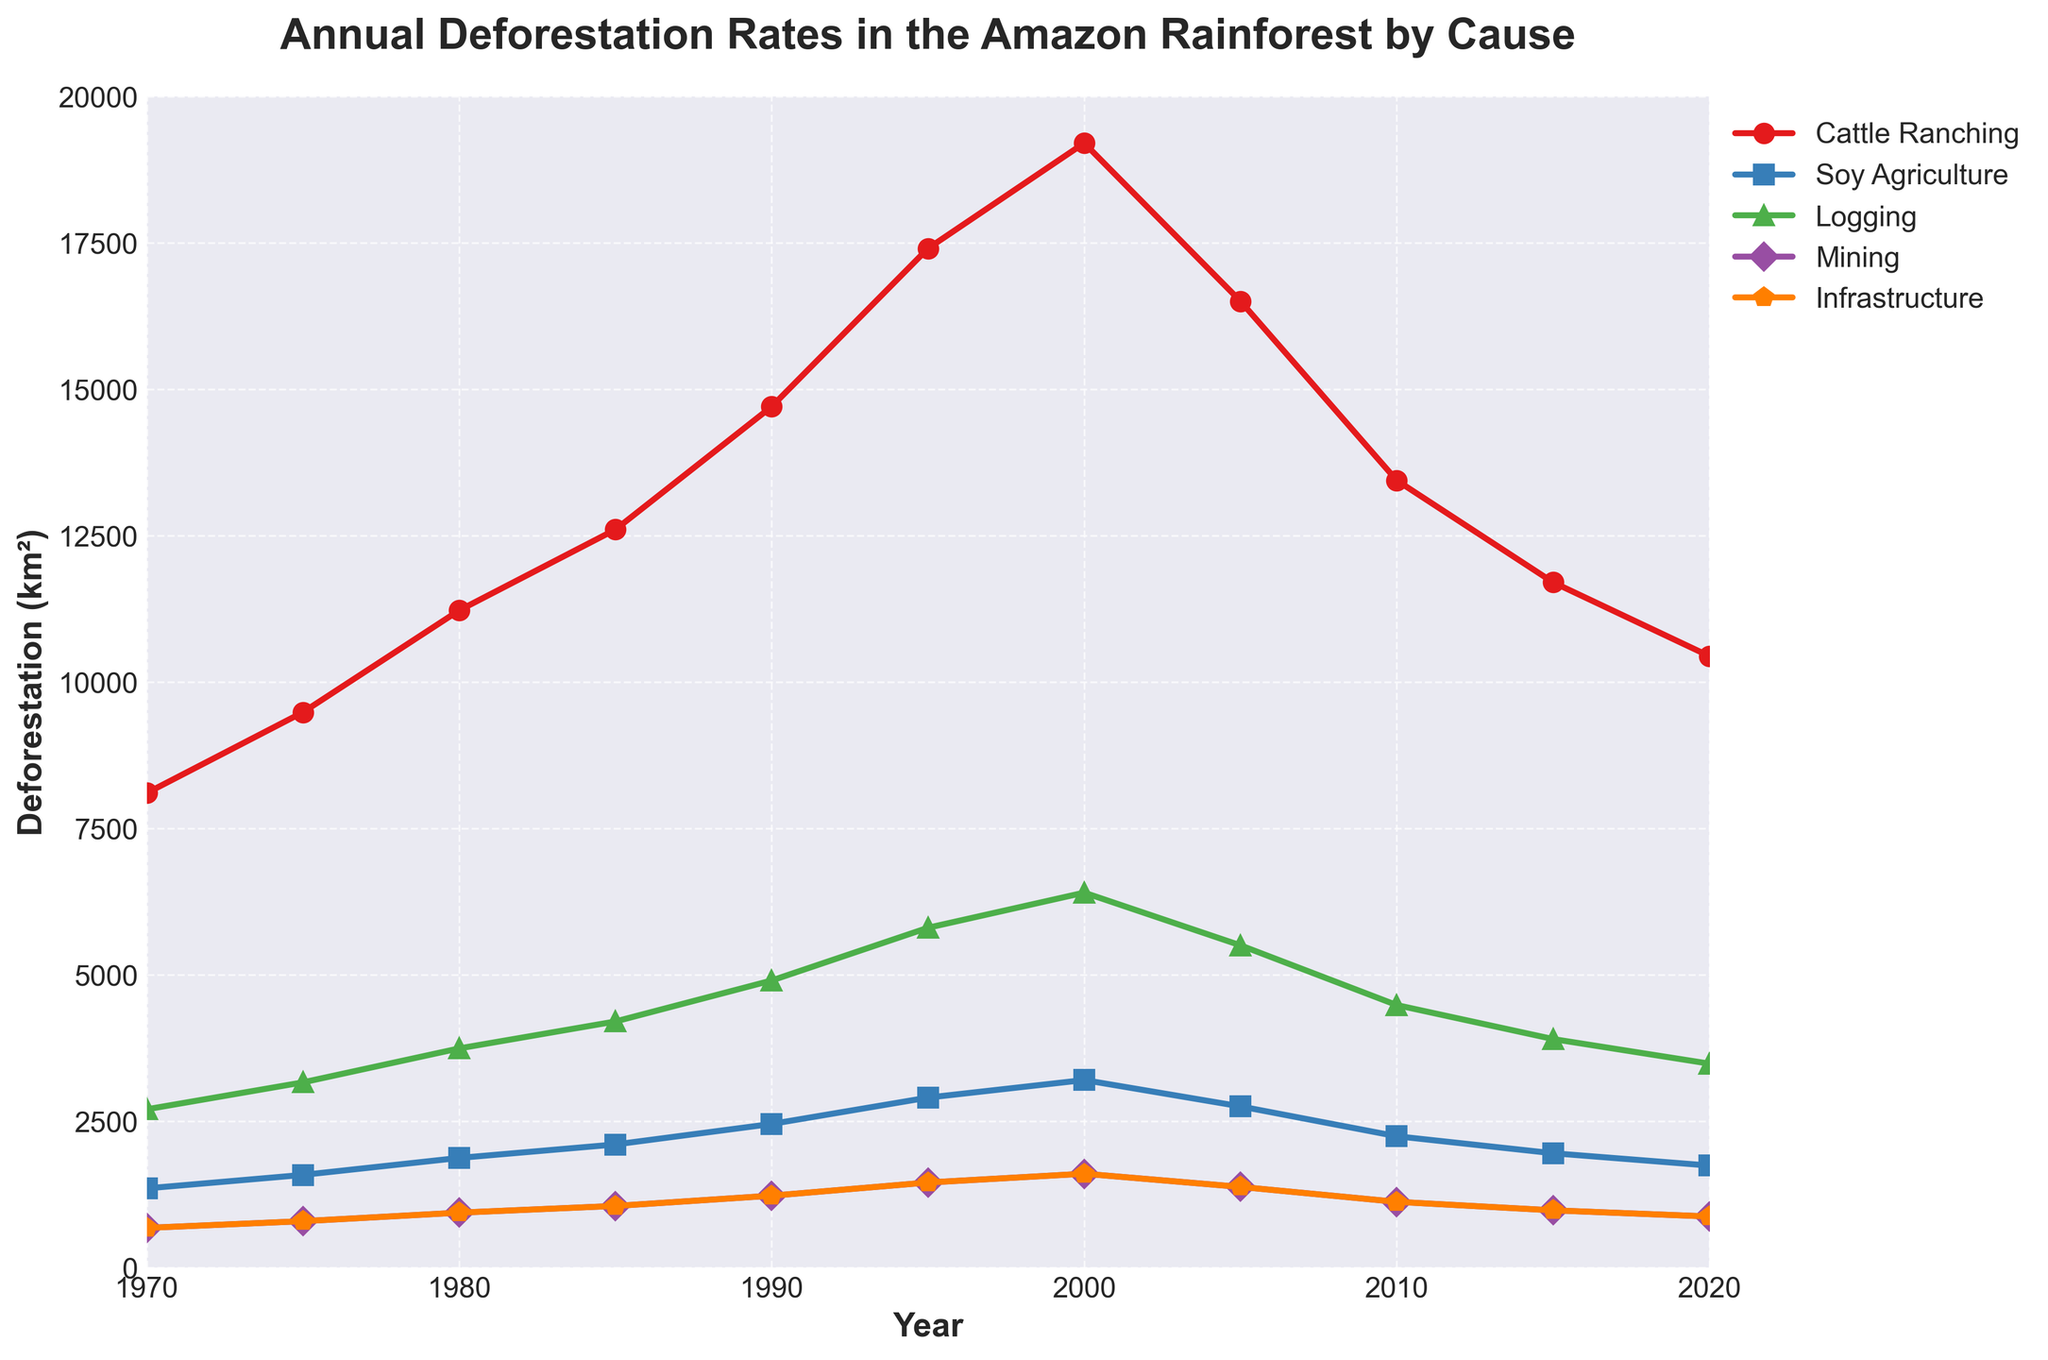What was the total deforestation caused by cattle ranching in 1980? The figure shows that the deforestation caused by cattle ranching in 1980 is indicated by the height of the respective line on the plot. The value at 1980 for cattle ranching is 11220 km².
Answer: 11220 km² Between 1975 and 2000, which cause of deforestation had the greatest increase? By comparing the values at 1975 and 2000 for all causes, we observe the following increases: cattle ranching (19200 - 9480 = 9720 km²), soy agriculture (3200 - 1580 = 1620 km²), logging (6400 - 3160 = 3240 km²), mining (1600 - 790 = 810 km²), and infrastructure (1600 - 790 = 810 km²). The greatest increase is in cattle ranching with an increment of 9720 km².
Answer: Cattle Ranching Which year had the highest total deforestation rate, and what was the value? The highest total deforestation rate corresponds to the highest point on the 'Total Deforestation' line. The figure shows that the peak occurred in 2000 with a value of 32000 km².
Answer: 2000, 32000 km² Compare the deforestation caused by logging and mining in 1990. Which was higher, and by how much? The figure shows the deforestation for logging in 1990 is 4900 km² and for mining is 1225 km². Logging is higher. The difference is 4900 - 1225 = 3675 km².
Answer: Logging by 3675 km² What is the average annual deforestation caused by infrastructure from 1970 to 2020? Sum the values for infrastructure from 1970 to 2020 (675 + 790 + 935 + 1050 + 1225 + 1450 + 1600 + 1375 + 1120 + 975 + 870 = 12065 km²) and then divide by the number of years (2020 - 1970 = 50 years). The average annual deforestation is 12065 / 50 = 241.3 km².
Answer: 241.3 km² Identify the two primary causes of deforestation and explain how their trend lines differ over the period from 1970 to 2020. The primary causes are cattle ranching and soy agriculture. Cattle ranching shows a steady increase, peaking in 2000 and slightly declining afterward. Soy agriculture peaks similarly but at a much lower value. Over time, cattle ranching consistently causes more deforestation compared to soy agriculture.
Answer: Cattle Ranching increased more steadily; Soy agriculture was always lower By how much did the total deforestation rate change from 2000 to 2005? The total deforestation in 2000 is 32000 km² and in 2005 is 27500 km². The change is 32000 - 27500 = -4500 km². This represents a decrease in the deforestation rate.
Answer: -4500 km² What is the second most significant cause of deforestation in 1995, and what is its value? In 1995, cattle ranching is the primary cause. The second highest line would be logging at 5800 km², higher than soy agriculture, mining, and infrastructure.
Answer: Logging, 5800 km² 